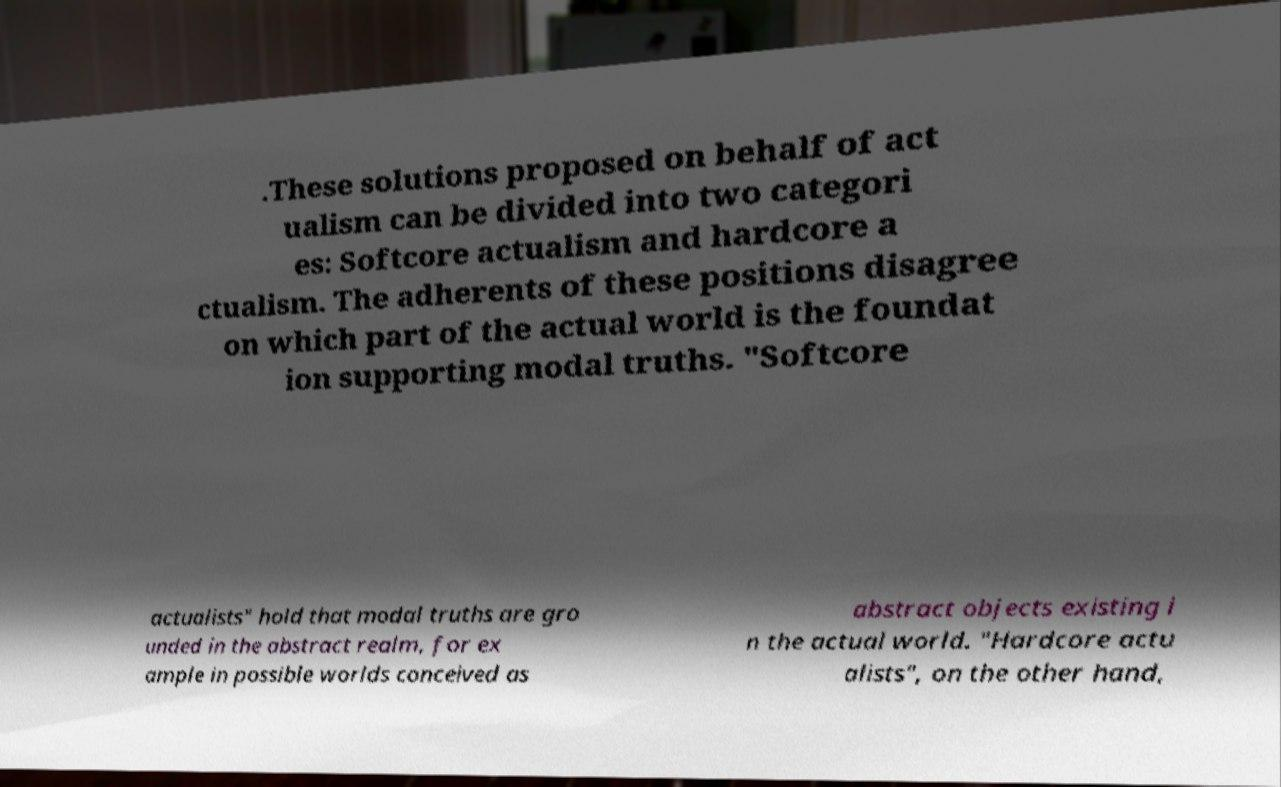I need the written content from this picture converted into text. Can you do that? .These solutions proposed on behalf of act ualism can be divided into two categori es: Softcore actualism and hardcore a ctualism. The adherents of these positions disagree on which part of the actual world is the foundat ion supporting modal truths. "Softcore actualists" hold that modal truths are gro unded in the abstract realm, for ex ample in possible worlds conceived as abstract objects existing i n the actual world. "Hardcore actu alists", on the other hand, 